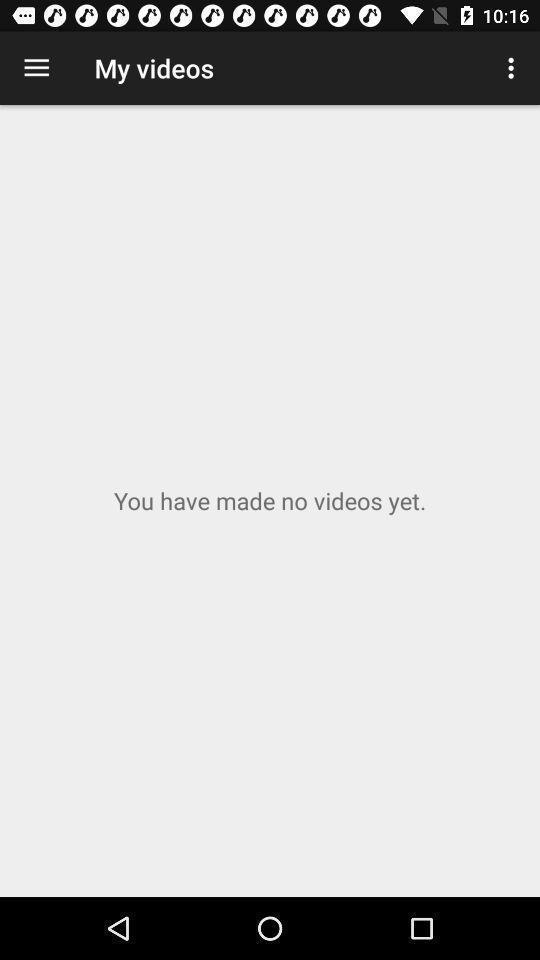Give me a narrative description of this picture. Screen displaying my videos page. 